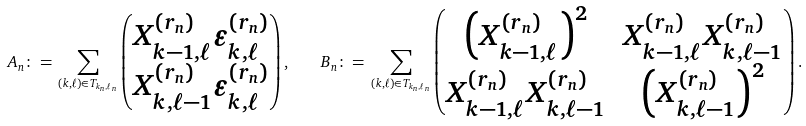<formula> <loc_0><loc_0><loc_500><loc_500>A _ { n } \colon = \, \sum _ { ( k , \ell ) \in T _ { k _ { n } , \ell _ { n } } } \begin{pmatrix} X _ { k - 1 , \ell } ^ { ( r _ { n } ) } \varepsilon _ { k , \ell } ^ { ( r _ { n } ) } \\ X _ { k , \ell - 1 } ^ { ( r _ { n } ) } \varepsilon _ { k , \ell } ^ { ( r _ { n } ) } \end{pmatrix} , \quad B _ { n } \colon = \, \sum _ { ( k , \ell ) \in T _ { k _ { n } , \ell _ { n } } } \begin{pmatrix} \left ( X _ { k - 1 , \ell } ^ { ( r _ { n } ) } \right ) ^ { 2 } & X _ { k - 1 , \ell } ^ { ( r _ { n } ) } X _ { k , \ell - 1 } ^ { ( r _ { n } ) } \\ X _ { k - 1 , \ell } ^ { ( r _ { n } ) } X _ { k , \ell - 1 } ^ { ( r _ { n } ) } & \left ( X _ { k , \ell - 1 } ^ { ( r _ { n } ) } \right ) ^ { 2 } \end{pmatrix} .</formula> 